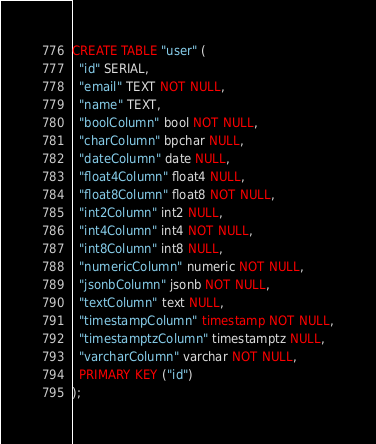<code> <loc_0><loc_0><loc_500><loc_500><_SQL_>CREATE TABLE "user" (
  "id" SERIAL,
  "email" TEXT NOT NULL,
  "name" TEXT,
  "boolColumn" bool NOT NULL,
  "charColumn" bpchar NULL,
  "dateColumn" date NULL,
  "float4Column" float4 NULL,
  "float8Column" float8 NOT NULL,
  "int2Column" int2 NULL,
  "int4Column" int4 NOT NULL,
  "int8Column" int8 NULL,
  "numericColumn" numeric NOT NULL,
  "jsonbColumn" jsonb NOT NULL,
  "textColumn" text NULL,
  "timestampColumn" timestamp NOT NULL,
  "timestamptzColumn" timestamptz NULL,
  "varcharColumn" varchar NOT NULL,
  PRIMARY KEY ("id")
);

</code> 